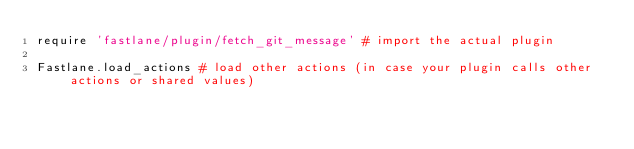<code> <loc_0><loc_0><loc_500><loc_500><_Ruby_>require 'fastlane/plugin/fetch_git_message' # import the actual plugin

Fastlane.load_actions # load other actions (in case your plugin calls other actions or shared values)
</code> 